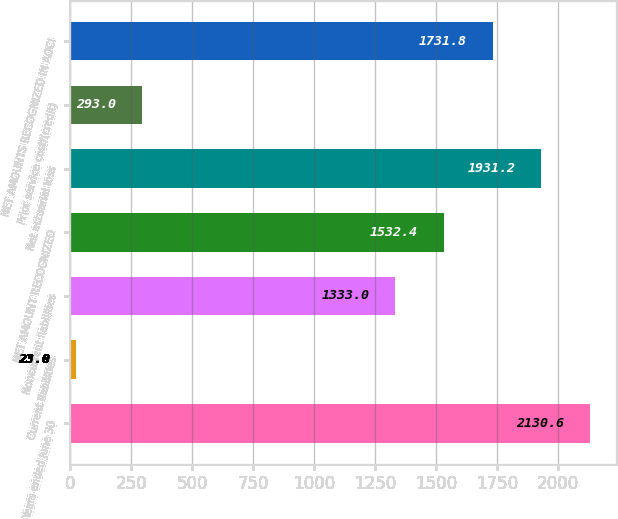Convert chart to OTSL. <chart><loc_0><loc_0><loc_500><loc_500><bar_chart><fcel>Years ended June 30<fcel>Current liabilities<fcel>Noncurrent liabilities<fcel>NET AMOUNT RECOGNIZED<fcel>Net actuarial loss<fcel>Prior service cost/(credit)<fcel>NET AMOUNTS RECOGNIZED IN AOCI<nl><fcel>2130.6<fcel>23<fcel>1333<fcel>1532.4<fcel>1931.2<fcel>293<fcel>1731.8<nl></chart> 